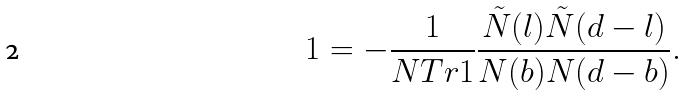<formula> <loc_0><loc_0><loc_500><loc_500>1 = - \frac { 1 } { N T r 1 } \frac { \tilde { N } ( l ) \tilde { N } ( d - l ) } { N ( b ) N ( d - b ) } .</formula> 